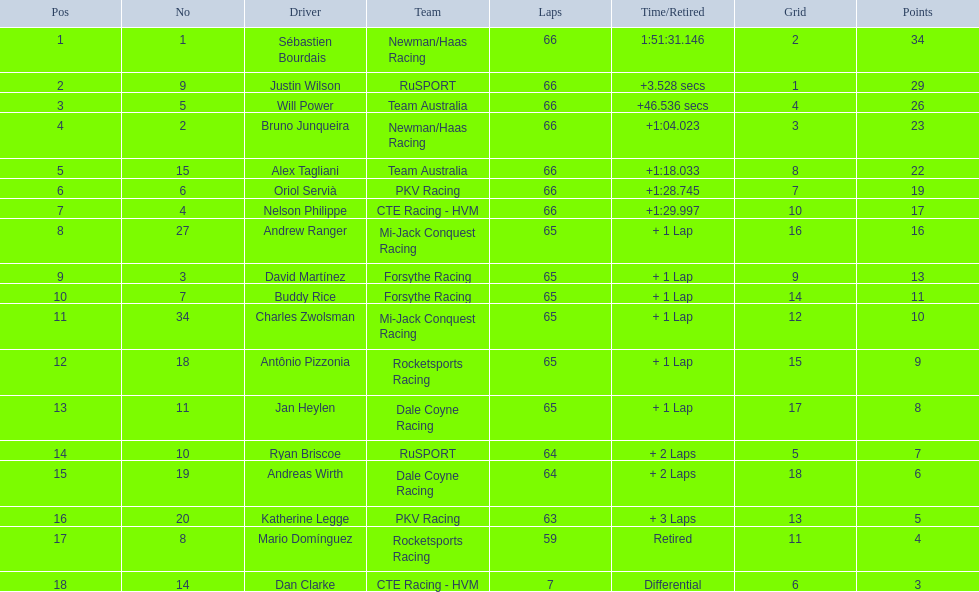What was the point tally for the first-place finisher? 34. How many points did the last-place finisher get? 3. Can you identify the individual who received the least points? Dan Clarke. 